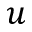<formula> <loc_0><loc_0><loc_500><loc_500>u</formula> 